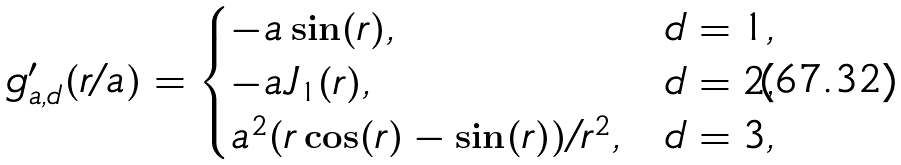Convert formula to latex. <formula><loc_0><loc_0><loc_500><loc_500>g _ { a , d } ^ { \prime } ( r / a ) = \begin{cases} - a \sin ( r ) , & d = 1 , \\ - a J _ { 1 } ( r ) , & d = 2 , \\ a ^ { 2 } ( r \cos ( r ) - \sin ( r ) ) / r ^ { 2 } , & d = 3 , \end{cases}</formula> 